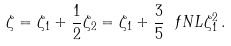Convert formula to latex. <formula><loc_0><loc_0><loc_500><loc_500>\zeta = \zeta _ { 1 } + \frac { 1 } { 2 } \zeta _ { 2 } = \zeta _ { 1 } + \frac { 3 } { 5 } \ f N L \zeta _ { 1 } ^ { 2 } \, .</formula> 